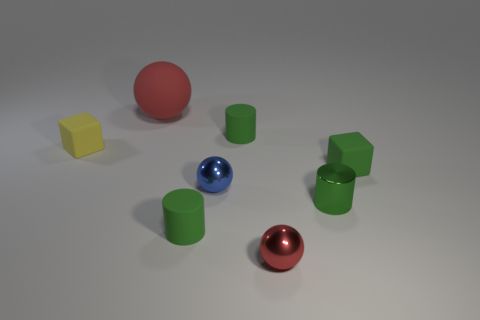There is a green matte object that is behind the object that is left of the big red rubber object; what shape is it? cylinder 